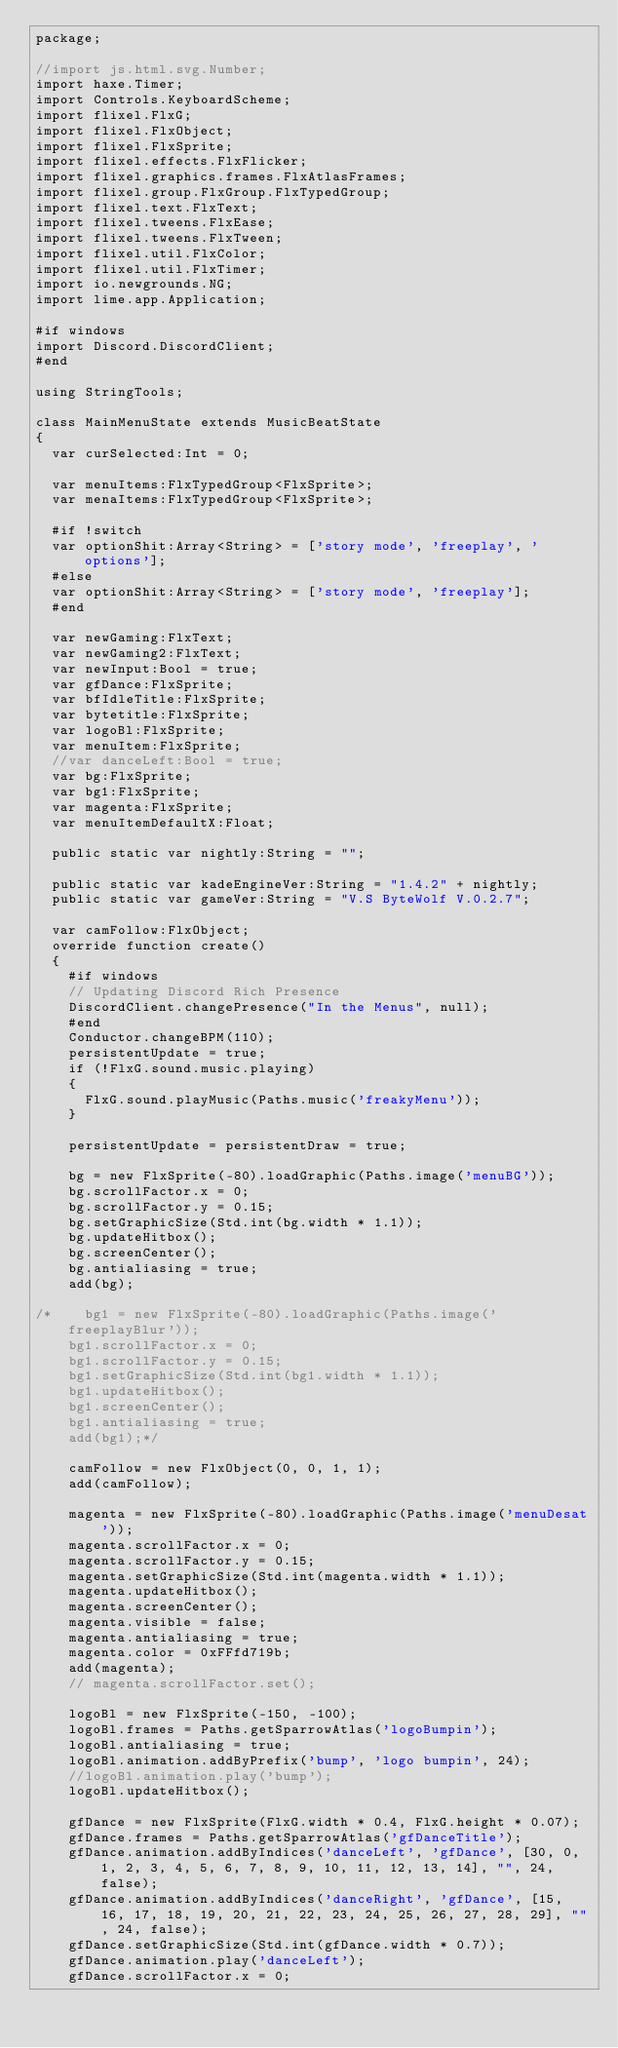<code> <loc_0><loc_0><loc_500><loc_500><_Haxe_>package;

//import js.html.svg.Number;
import haxe.Timer;
import Controls.KeyboardScheme;
import flixel.FlxG;
import flixel.FlxObject;
import flixel.FlxSprite;
import flixel.effects.FlxFlicker;
import flixel.graphics.frames.FlxAtlasFrames;
import flixel.group.FlxGroup.FlxTypedGroup;
import flixel.text.FlxText;
import flixel.tweens.FlxEase;
import flixel.tweens.FlxTween;
import flixel.util.FlxColor;
import flixel.util.FlxTimer;
import io.newgrounds.NG;
import lime.app.Application;

#if windows
import Discord.DiscordClient;
#end

using StringTools;

class MainMenuState extends MusicBeatState
{
	var curSelected:Int = 0;

	var menuItems:FlxTypedGroup<FlxSprite>;
	var menaItems:FlxTypedGroup<FlxSprite>;

	#if !switch
	var optionShit:Array<String> = ['story mode', 'freeplay', 'options'];
	#else
	var optionShit:Array<String> = ['story mode', 'freeplay'];
	#end

	var newGaming:FlxText;
	var newGaming2:FlxText;
	var newInput:Bool = true;
	var gfDance:FlxSprite;
	var bfIdleTitle:FlxSprite;
	var bytetitle:FlxSprite;
	var logoBl:FlxSprite;
	var menuItem:FlxSprite;
	//var danceLeft:Bool = true;
	var bg:FlxSprite;
	var bg1:FlxSprite;
	var magenta:FlxSprite;
	var menuItemDefaultX:Float;

	public static var nightly:String = "";

	public static var kadeEngineVer:String = "1.4.2" + nightly;
	public static var gameVer:String = "V.S ByteWolf V.0.2.7";

	var camFollow:FlxObject;
	override function create()
	{
		#if windows
		// Updating Discord Rich Presence
		DiscordClient.changePresence("In the Menus", null);
		#end
		Conductor.changeBPM(110);
		persistentUpdate = true;
		if (!FlxG.sound.music.playing)
		{
			FlxG.sound.playMusic(Paths.music('freakyMenu'));
		}

		persistentUpdate = persistentDraw = true;

		bg = new FlxSprite(-80).loadGraphic(Paths.image('menuBG'));
		bg.scrollFactor.x = 0;
		bg.scrollFactor.y = 0.15;
		bg.setGraphicSize(Std.int(bg.width * 1.1));
		bg.updateHitbox();
		bg.screenCenter();
		bg.antialiasing = true;
		add(bg);

/*		bg1 = new FlxSprite(-80).loadGraphic(Paths.image('freeplayBlur'));
		bg1.scrollFactor.x = 0;
		bg1.scrollFactor.y = 0.15;
		bg1.setGraphicSize(Std.int(bg1.width * 1.1));
		bg1.updateHitbox();
		bg1.screenCenter();
		bg1.antialiasing = true;
		add(bg1);*/

		camFollow = new FlxObject(0, 0, 1, 1);
		add(camFollow);

		magenta = new FlxSprite(-80).loadGraphic(Paths.image('menuDesat'));
		magenta.scrollFactor.x = 0;
		magenta.scrollFactor.y = 0.15;
		magenta.setGraphicSize(Std.int(magenta.width * 1.1));
		magenta.updateHitbox();
		magenta.screenCenter();
		magenta.visible = false;
		magenta.antialiasing = true;
		magenta.color = 0xFFfd719b;
		add(magenta);
		// magenta.scrollFactor.set();

		logoBl = new FlxSprite(-150, -100);
		logoBl.frames = Paths.getSparrowAtlas('logoBumpin');
		logoBl.antialiasing = true;
		logoBl.animation.addByPrefix('bump', 'logo bumpin', 24);
		//logoBl.animation.play('bump');
		logoBl.updateHitbox();

		gfDance = new FlxSprite(FlxG.width * 0.4, FlxG.height * 0.07);
		gfDance.frames = Paths.getSparrowAtlas('gfDanceTitle');
		gfDance.animation.addByIndices('danceLeft', 'gfDance', [30, 0, 1, 2, 3, 4, 5, 6, 7, 8, 9, 10, 11, 12, 13, 14], "", 24, false);
		gfDance.animation.addByIndices('danceRight', 'gfDance', [15, 16, 17, 18, 19, 20, 21, 22, 23, 24, 25, 26, 27, 28, 29], "", 24, false);
		gfDance.setGraphicSize(Std.int(gfDance.width * 0.7));
		gfDance.animation.play('danceLeft');
		gfDance.scrollFactor.x = 0;</code> 